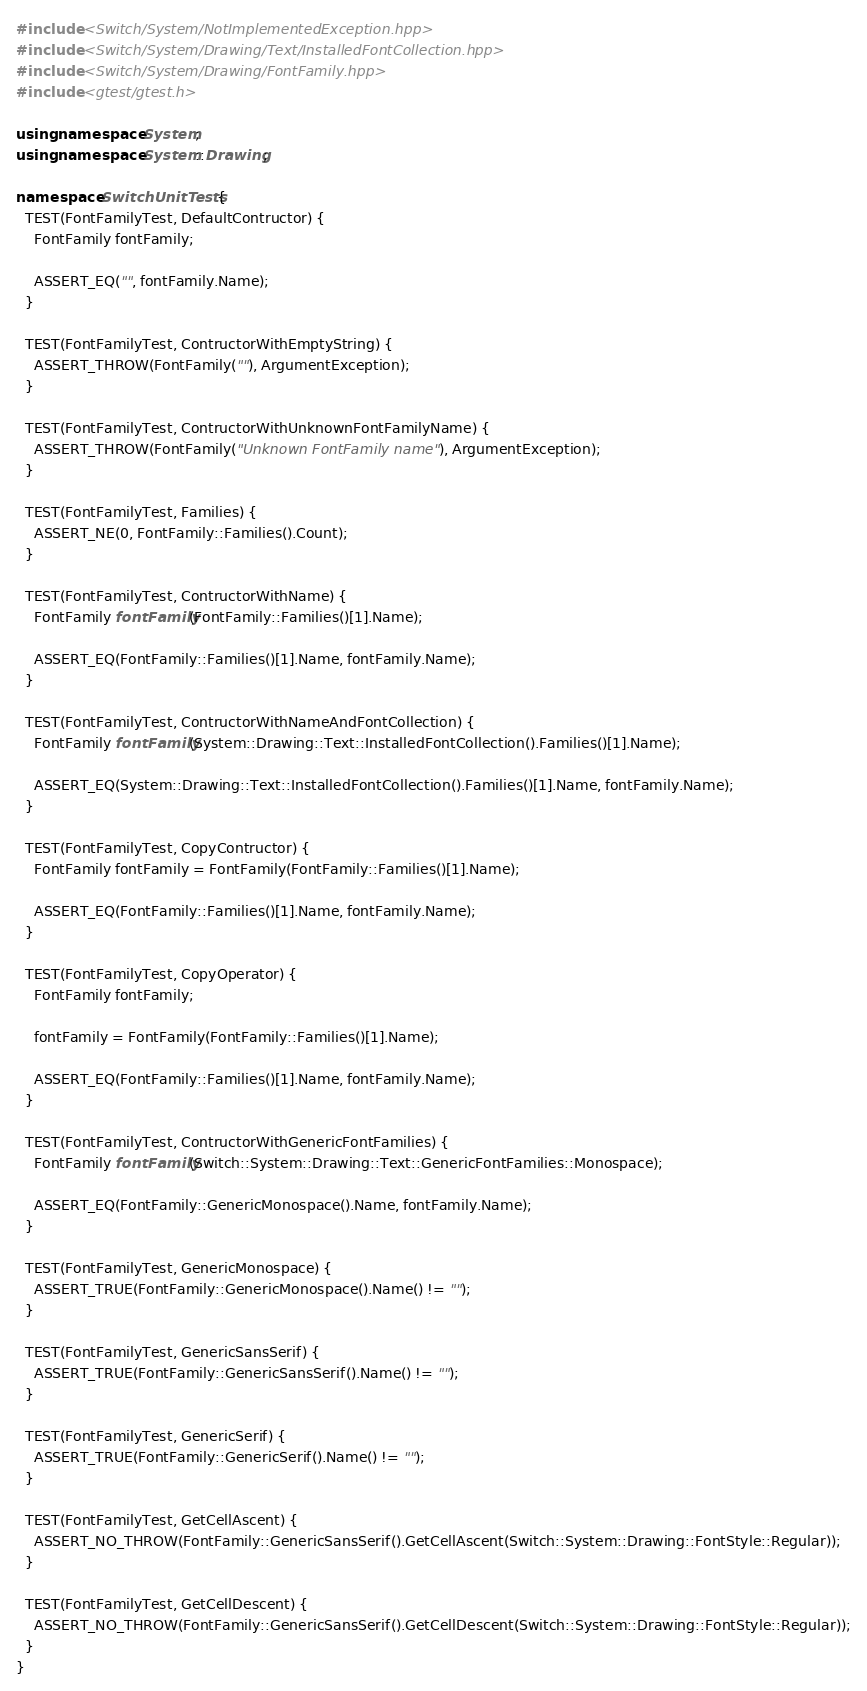Convert code to text. <code><loc_0><loc_0><loc_500><loc_500><_C++_>#include <Switch/System/NotImplementedException.hpp>
#include <Switch/System/Drawing/Text/InstalledFontCollection.hpp>
#include <Switch/System/Drawing/FontFamily.hpp>
#include <gtest/gtest.h>

using namespace System;
using namespace System::Drawing;

namespace SwitchUnitTests {
  TEST(FontFamilyTest, DefaultContructor) {
    FontFamily fontFamily;

    ASSERT_EQ("", fontFamily.Name);
  }

  TEST(FontFamilyTest, ContructorWithEmptyString) {
    ASSERT_THROW(FontFamily(""), ArgumentException);
  }

  TEST(FontFamilyTest, ContructorWithUnknownFontFamilyName) {
    ASSERT_THROW(FontFamily("Unknown FontFamily name"), ArgumentException);
  }

  TEST(FontFamilyTest, Families) {
    ASSERT_NE(0, FontFamily::Families().Count);
  }

  TEST(FontFamilyTest, ContructorWithName) {
    FontFamily fontFamily(FontFamily::Families()[1].Name);

    ASSERT_EQ(FontFamily::Families()[1].Name, fontFamily.Name);
  }

  TEST(FontFamilyTest, ContructorWithNameAndFontCollection) {
    FontFamily fontFamily(System::Drawing::Text::InstalledFontCollection().Families()[1].Name);

    ASSERT_EQ(System::Drawing::Text::InstalledFontCollection().Families()[1].Name, fontFamily.Name);
  }

  TEST(FontFamilyTest, CopyContructor) {
    FontFamily fontFamily = FontFamily(FontFamily::Families()[1].Name);

    ASSERT_EQ(FontFamily::Families()[1].Name, fontFamily.Name);
  }

  TEST(FontFamilyTest, CopyOperator) {
    FontFamily fontFamily;

    fontFamily = FontFamily(FontFamily::Families()[1].Name);

    ASSERT_EQ(FontFamily::Families()[1].Name, fontFamily.Name);
  }

  TEST(FontFamilyTest, ContructorWithGenericFontFamilies) {
    FontFamily fontFamily(Switch::System::Drawing::Text::GenericFontFamilies::Monospace);

    ASSERT_EQ(FontFamily::GenericMonospace().Name, fontFamily.Name);
  }

  TEST(FontFamilyTest, GenericMonospace) {
    ASSERT_TRUE(FontFamily::GenericMonospace().Name() != "");
  }

  TEST(FontFamilyTest, GenericSansSerif) {
    ASSERT_TRUE(FontFamily::GenericSansSerif().Name() != "");
  }

  TEST(FontFamilyTest, GenericSerif) {
    ASSERT_TRUE(FontFamily::GenericSerif().Name() != "");
  }

  TEST(FontFamilyTest, GetCellAscent) {
    ASSERT_NO_THROW(FontFamily::GenericSansSerif().GetCellAscent(Switch::System::Drawing::FontStyle::Regular));
  }

  TEST(FontFamilyTest, GetCellDescent) {
    ASSERT_NO_THROW(FontFamily::GenericSansSerif().GetCellDescent(Switch::System::Drawing::FontStyle::Regular));
  }
}
</code> 